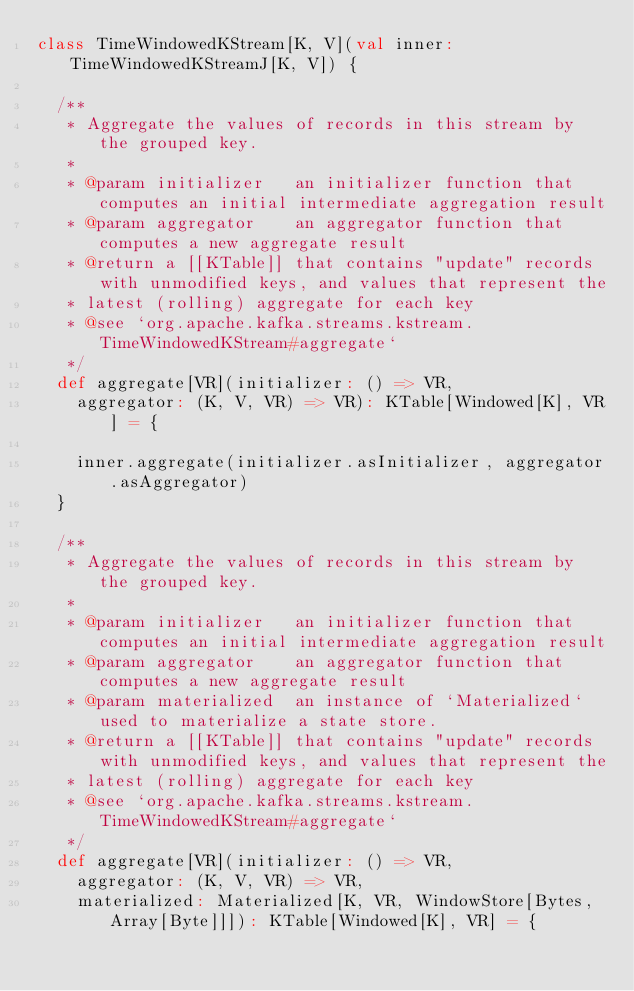Convert code to text. <code><loc_0><loc_0><loc_500><loc_500><_Scala_>class TimeWindowedKStream[K, V](val inner: TimeWindowedKStreamJ[K, V]) {

  /**
   * Aggregate the values of records in this stream by the grouped key.
   *
   * @param initializer   an initializer function that computes an initial intermediate aggregation result
   * @param aggregator    an aggregator function that computes a new aggregate result
   * @return a [[KTable]] that contains "update" records with unmodified keys, and values that represent the
   * latest (rolling) aggregate for each key
   * @see `org.apache.kafka.streams.kstream.TimeWindowedKStream#aggregate`
   */
  def aggregate[VR](initializer: () => VR,
    aggregator: (K, V, VR) => VR): KTable[Windowed[K], VR] = {

    inner.aggregate(initializer.asInitializer, aggregator.asAggregator)
  }

  /**
   * Aggregate the values of records in this stream by the grouped key.
   *
   * @param initializer   an initializer function that computes an initial intermediate aggregation result
   * @param aggregator    an aggregator function that computes a new aggregate result
   * @param materialized  an instance of `Materialized` used to materialize a state store. 
   * @return a [[KTable]] that contains "update" records with unmodified keys, and values that represent the
   * latest (rolling) aggregate for each key
   * @see `org.apache.kafka.streams.kstream.TimeWindowedKStream#aggregate`
   */
  def aggregate[VR](initializer: () => VR,
    aggregator: (K, V, VR) => VR,
    materialized: Materialized[K, VR, WindowStore[Bytes, Array[Byte]]]): KTable[Windowed[K], VR] = {
</code> 